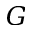<formula> <loc_0><loc_0><loc_500><loc_500>G</formula> 